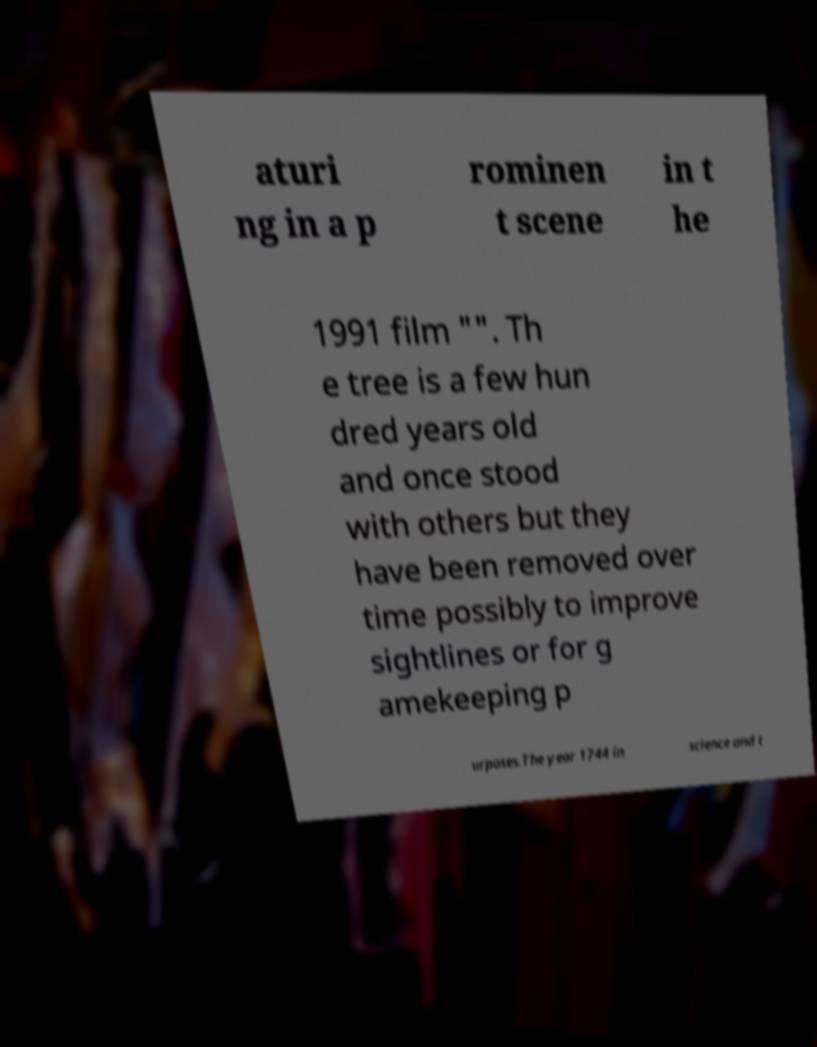Can you accurately transcribe the text from the provided image for me? aturi ng in a p rominen t scene in t he 1991 film "". Th e tree is a few hun dred years old and once stood with others but they have been removed over time possibly to improve sightlines or for g amekeeping p urposes.The year 1744 in science and t 